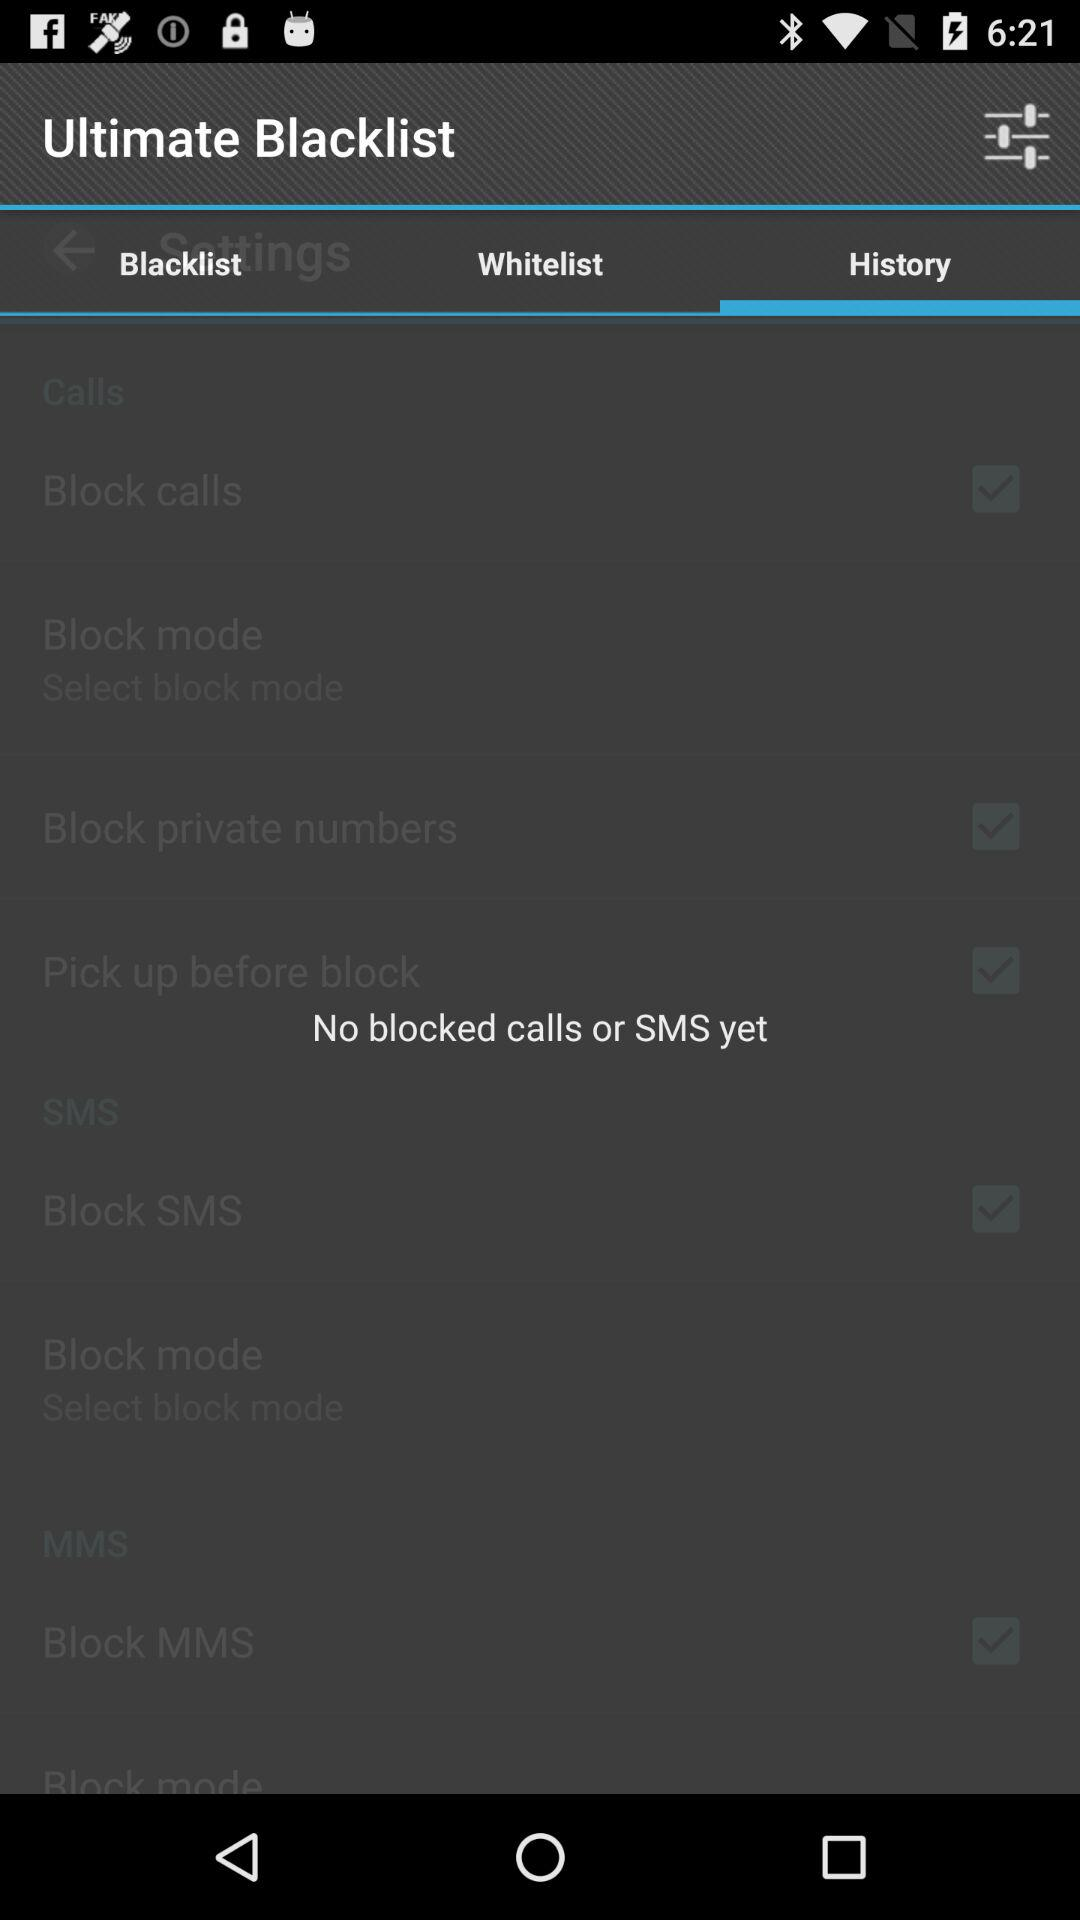How many times has "Ultimate Blacklist" been downloaded?
When the provided information is insufficient, respond with <no answer>. <no answer> 